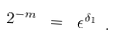<formula> <loc_0><loc_0><loc_500><loc_500>2 ^ { - m } \ = \ \epsilon ^ { \delta _ { 1 } } \ .</formula> 